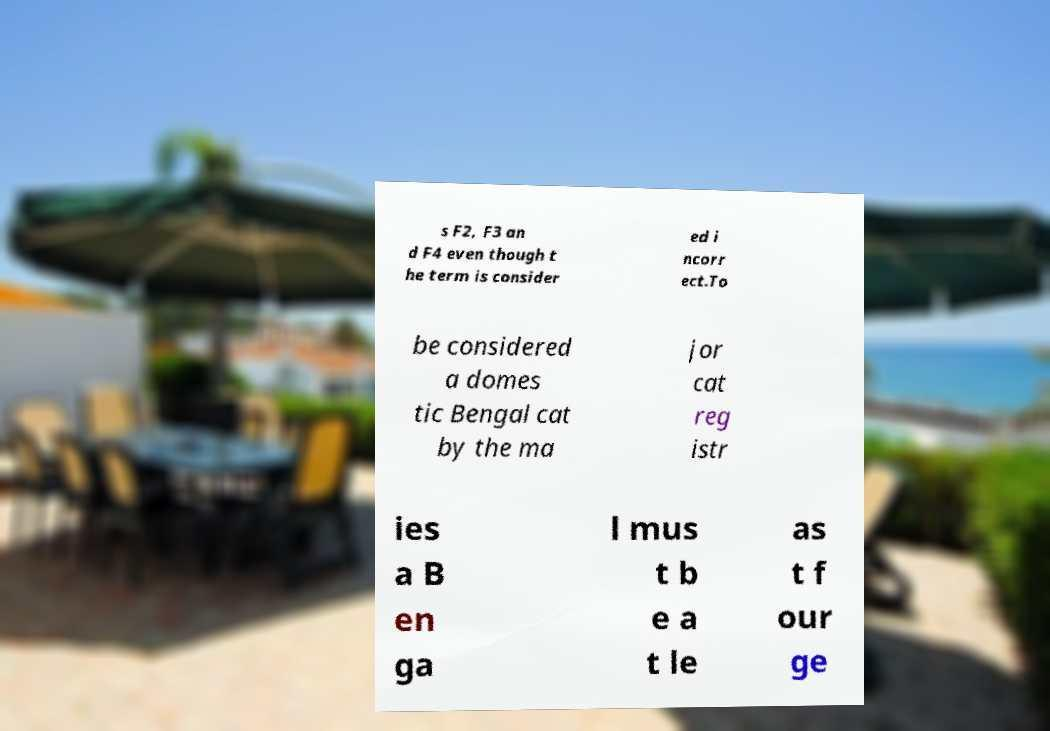Can you read and provide the text displayed in the image?This photo seems to have some interesting text. Can you extract and type it out for me? s F2, F3 an d F4 even though t he term is consider ed i ncorr ect.To be considered a domes tic Bengal cat by the ma jor cat reg istr ies a B en ga l mus t b e a t le as t f our ge 